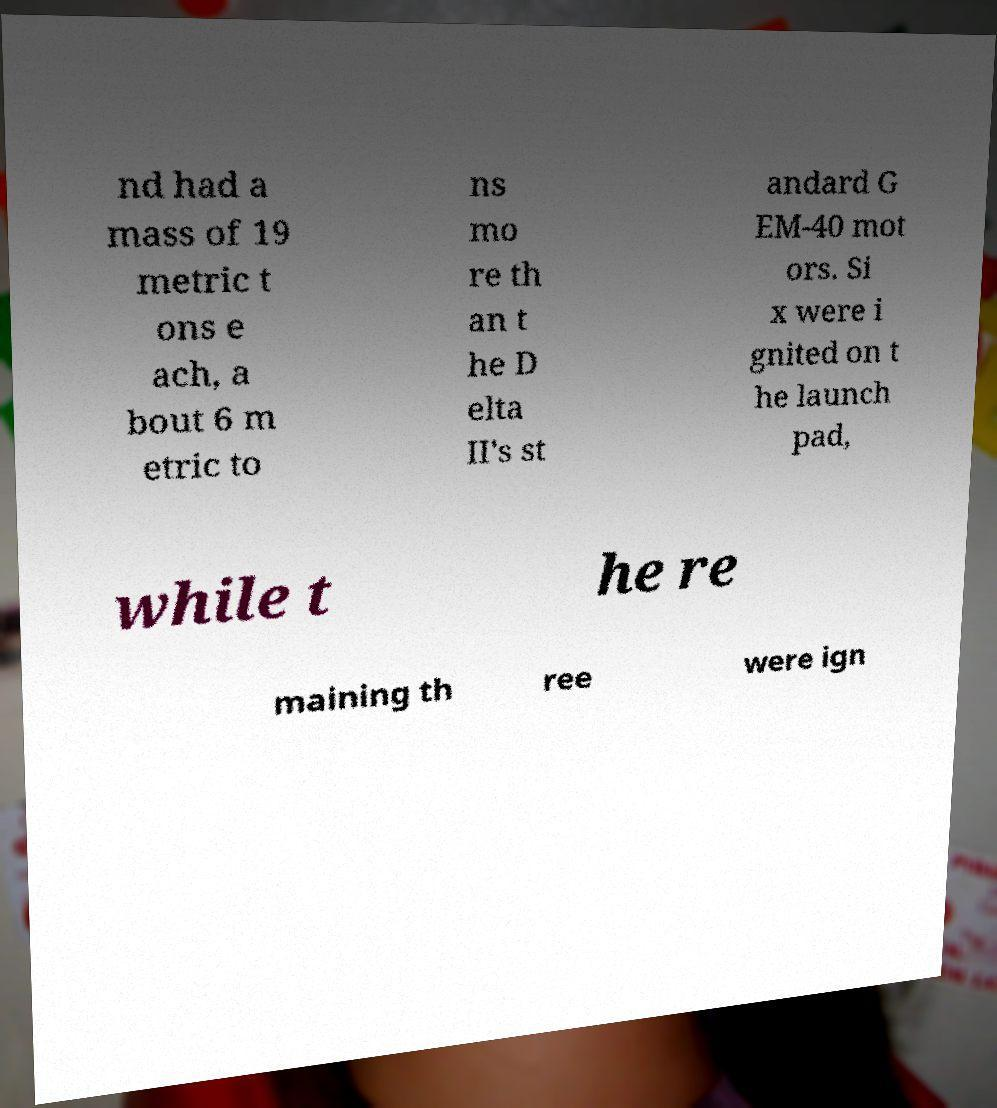Could you assist in decoding the text presented in this image and type it out clearly? nd had a mass of 19 metric t ons e ach, a bout 6 m etric to ns mo re th an t he D elta II's st andard G EM-40 mot ors. Si x were i gnited on t he launch pad, while t he re maining th ree were ign 